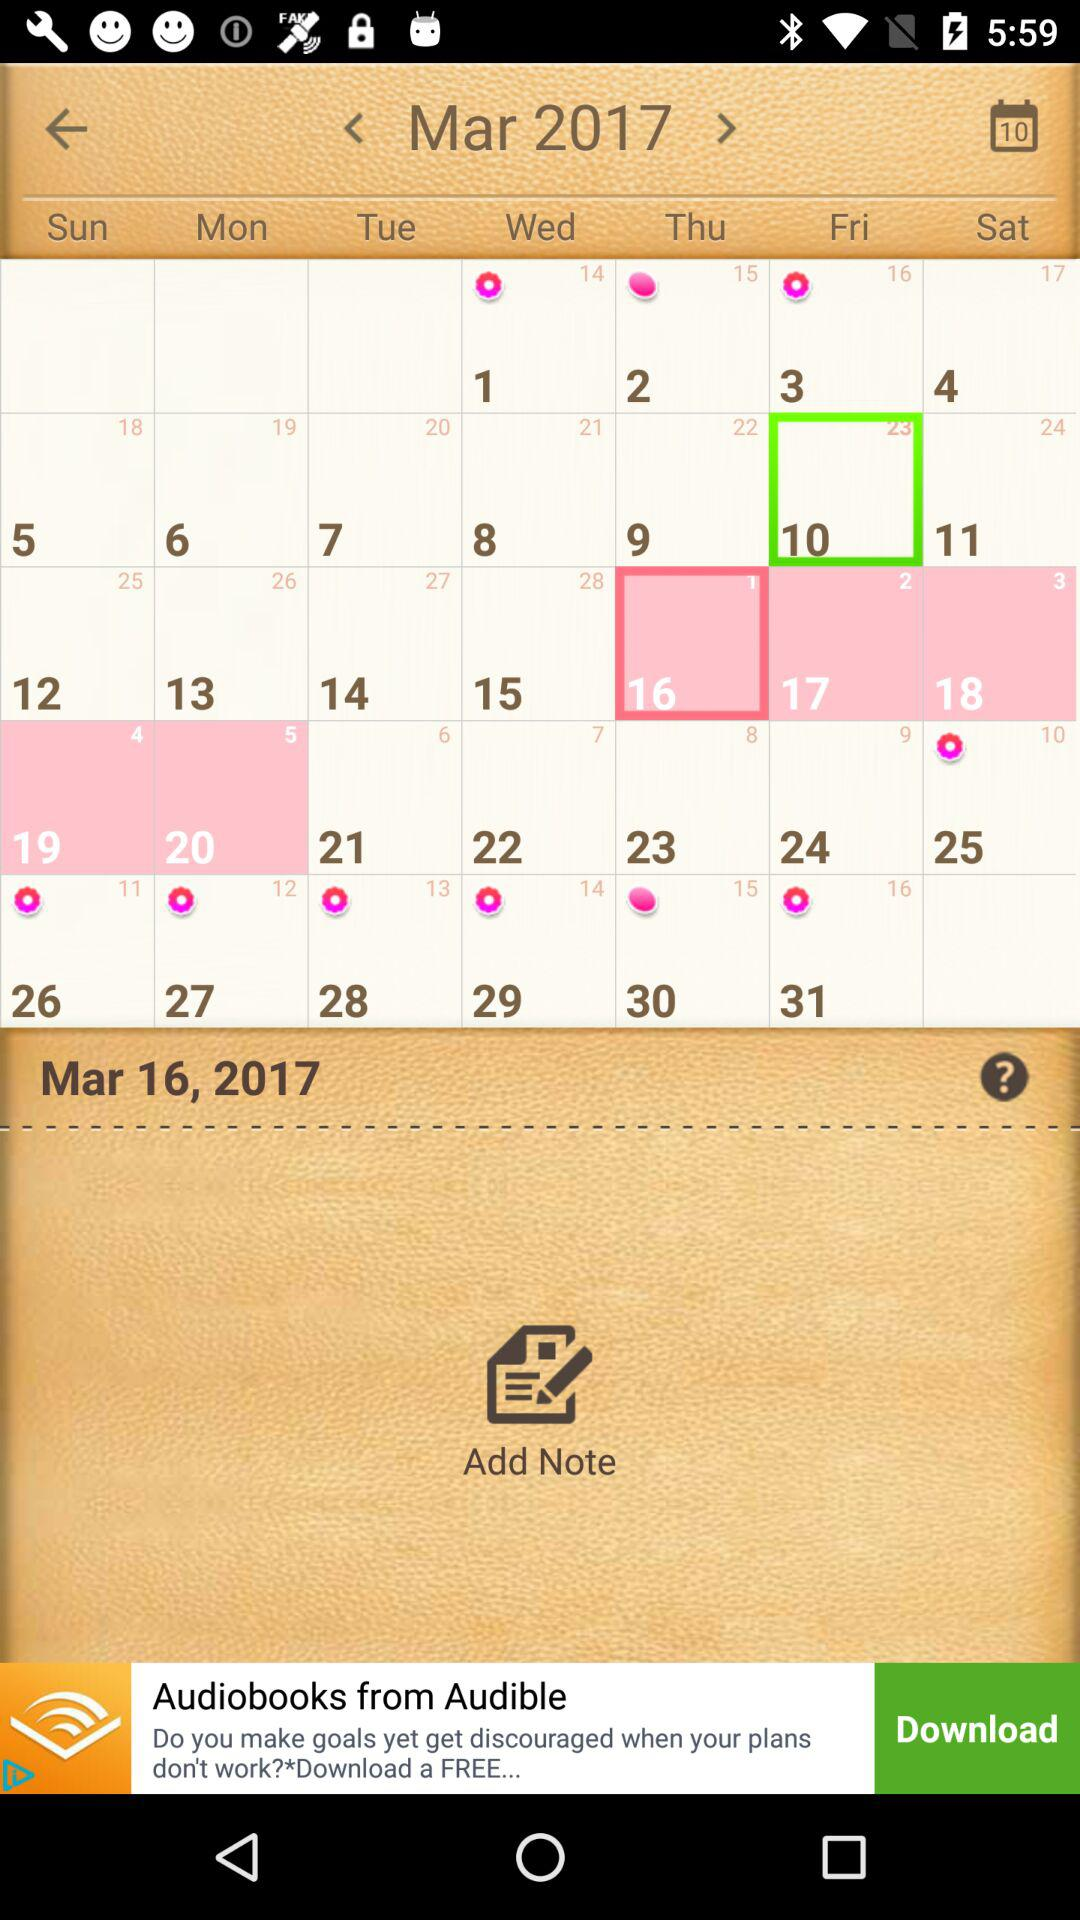What is the selected date? The selected date is Mar 16, 2017. 